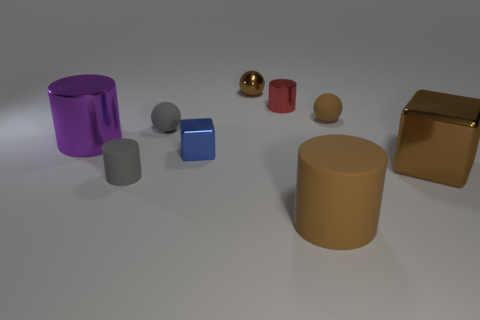Is there a sphere that has the same color as the big matte cylinder?
Your answer should be very brief. Yes. There is a brown shiny thing in front of the metal ball; what shape is it?
Your response must be concise. Cube. Does the small matte sphere that is on the right side of the brown rubber cylinder have the same color as the big block?
Offer a very short reply. Yes. Is the material of the red cylinder the same as the large brown cylinder?
Your answer should be compact. No. Are there any brown matte objects right of the tiny metallic block that is in front of the rubber ball that is to the left of the large matte object?
Ensure brevity in your answer.  Yes. The large matte object is what color?
Give a very brief answer. Brown. The other metallic object that is the same size as the purple thing is what color?
Your answer should be very brief. Brown. There is a small matte thing to the right of the tiny metallic ball; is its shape the same as the small brown metallic thing?
Make the answer very short. Yes. There is a big cylinder behind the brown shiny thing that is to the right of the brown rubber object that is in front of the big brown cube; what color is it?
Offer a very short reply. Purple. Are any small red rubber cylinders visible?
Your answer should be compact. No. 